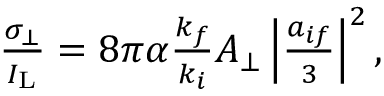Convert formula to latex. <formula><loc_0><loc_0><loc_500><loc_500>\begin{array} { r } { \frac { \sigma _ { \bot } } { I _ { L } } = 8 \pi \alpha \frac { k _ { f } } { k _ { i } } A _ { \bot } \left | \frac { a _ { i f } } { 3 } \right | ^ { 2 } , } \end{array}</formula> 